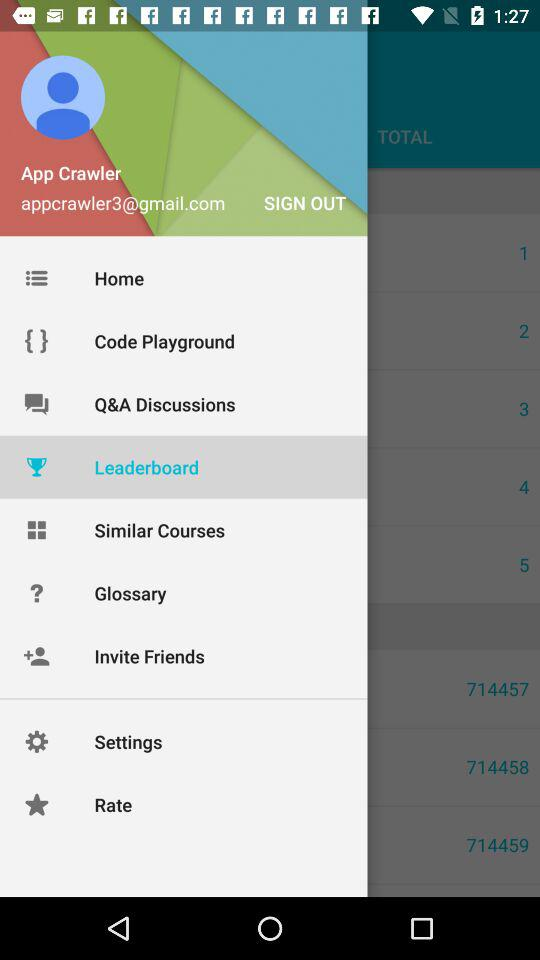Which item has been selected? The selected item is "Leaderboard". 